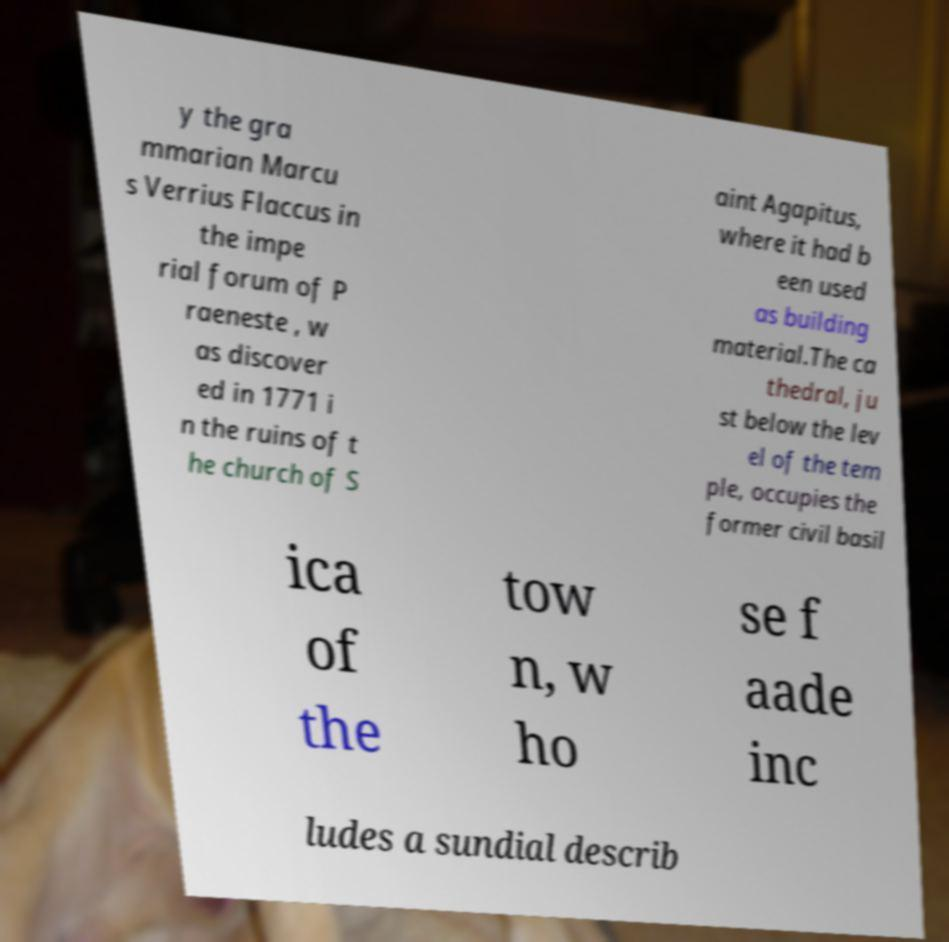What messages or text are displayed in this image? I need them in a readable, typed format. y the gra mmarian Marcu s Verrius Flaccus in the impe rial forum of P raeneste , w as discover ed in 1771 i n the ruins of t he church of S aint Agapitus, where it had b een used as building material.The ca thedral, ju st below the lev el of the tem ple, occupies the former civil basil ica of the tow n, w ho se f aade inc ludes a sundial describ 